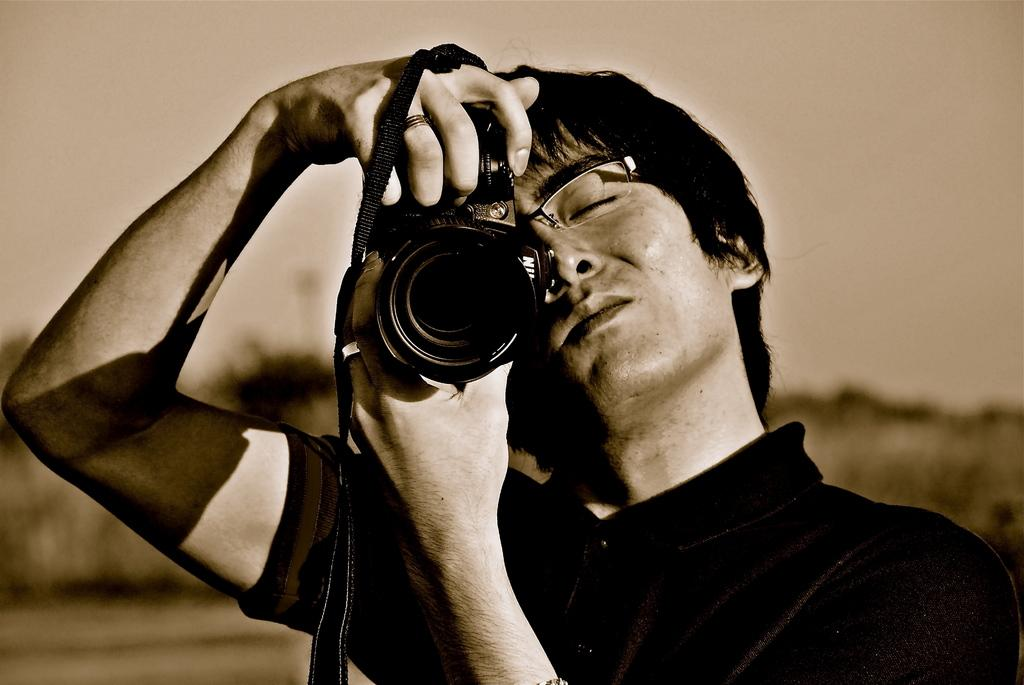What is the color scheme of the image? The image is black and white. Who is present in the image? There is a man in the image. What is the man wearing? The man is wearing a black t-shirt. What is the man holding in the image? The man is holding a camera. What accessory is the man wearing? The man is wearing spectacles. What can be seen behind the man in the image? There is a blue background behind the man. What type of card is the man holding in the image? There is no card present in the image; the man is holding a camera. What is the condition of the man's knee in the image? There is no information about the man's knee in the image, as it is not mentioned in the provided facts. 